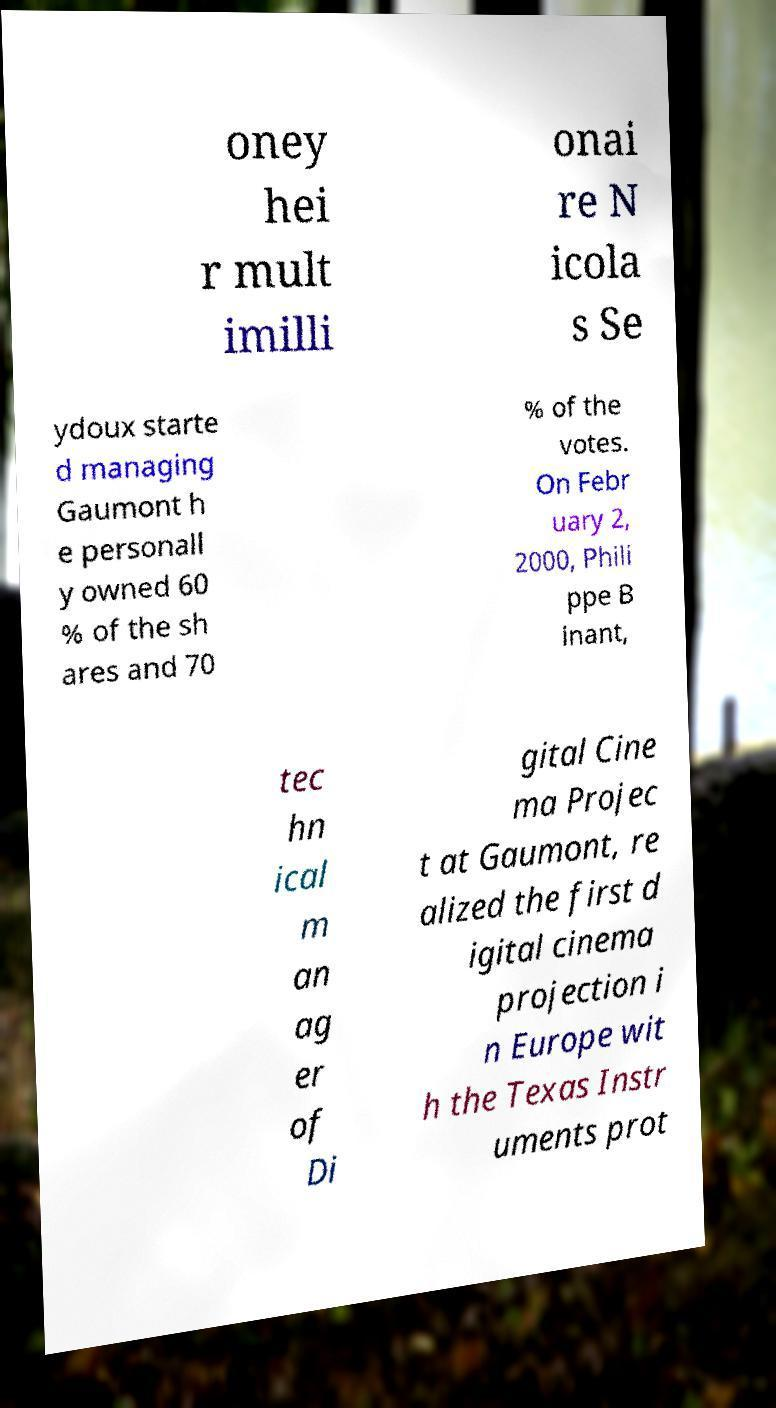Can you accurately transcribe the text from the provided image for me? oney hei r mult imilli onai re N icola s Se ydoux starte d managing Gaumont h e personall y owned 60 % of the sh ares and 70 % of the votes. On Febr uary 2, 2000, Phili ppe B inant, tec hn ical m an ag er of Di gital Cine ma Projec t at Gaumont, re alized the first d igital cinema projection i n Europe wit h the Texas Instr uments prot 